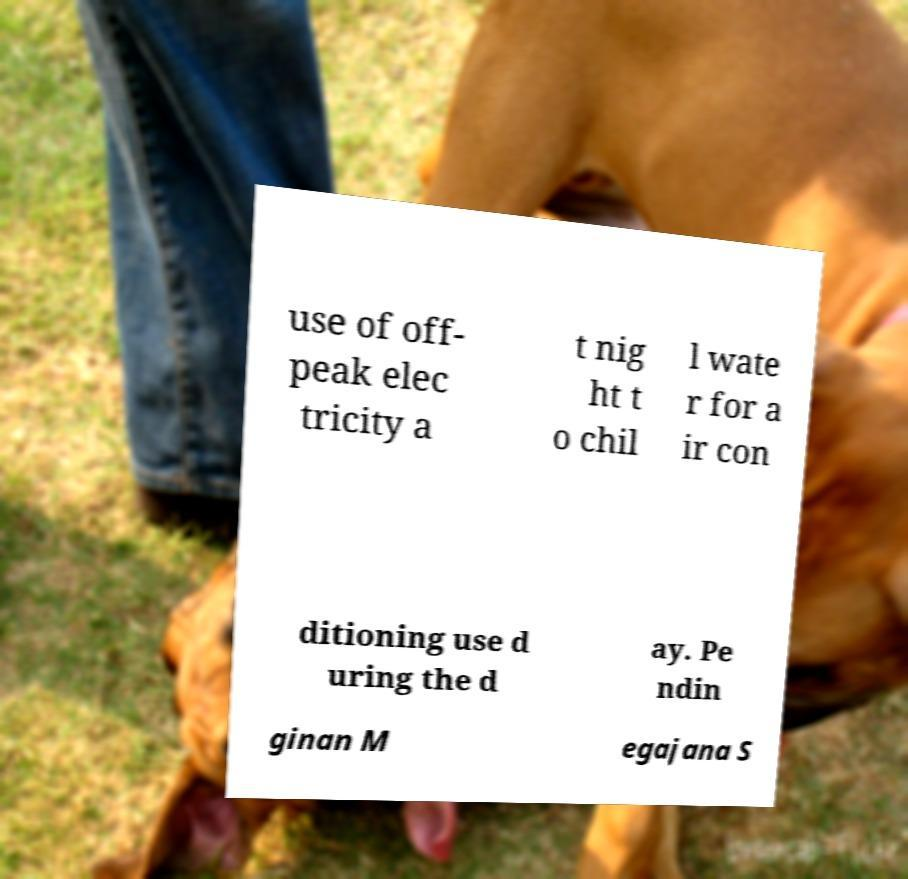What messages or text are displayed in this image? I need them in a readable, typed format. use of off- peak elec tricity a t nig ht t o chil l wate r for a ir con ditioning use d uring the d ay. Pe ndin ginan M egajana S 